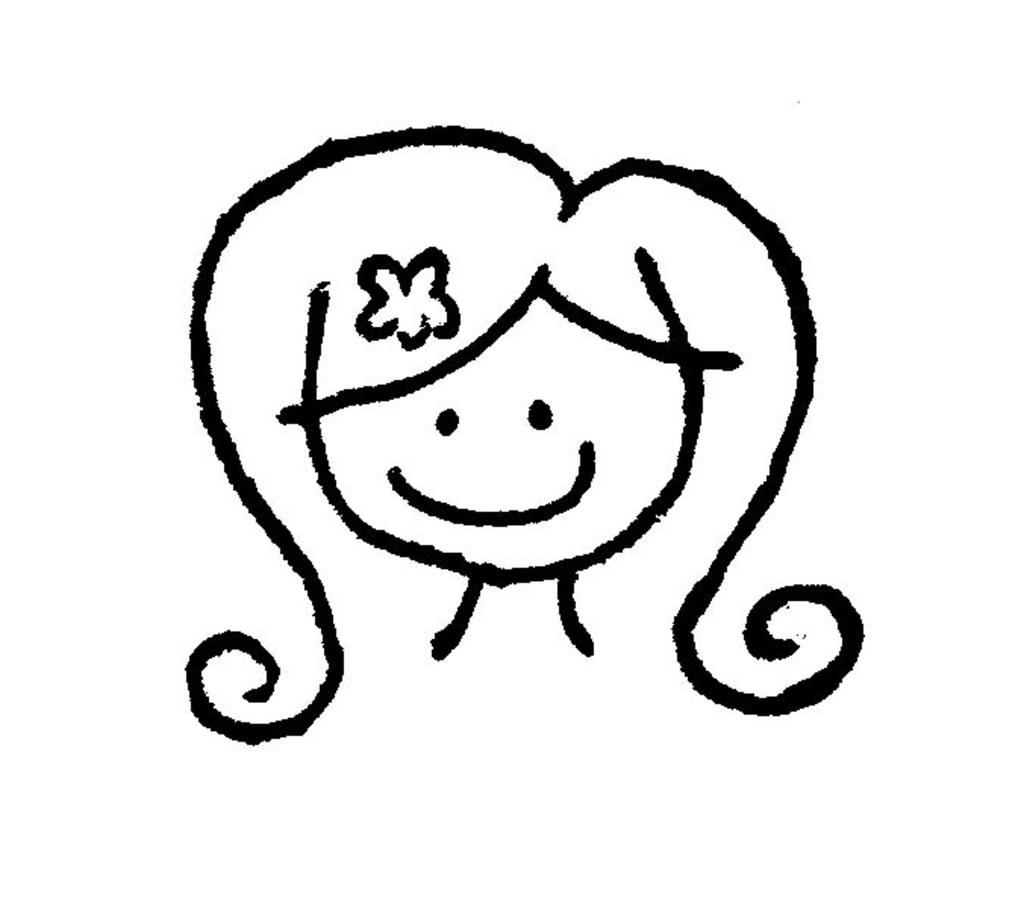What is depicted in the image? There is an art of a cartoon person in the image. What color is the background of the image? The background of the image is white. Can you see a frog smiling in the image? There is no frog or any indication of a smile in the image; it features an art of a cartoon person with a white background. 